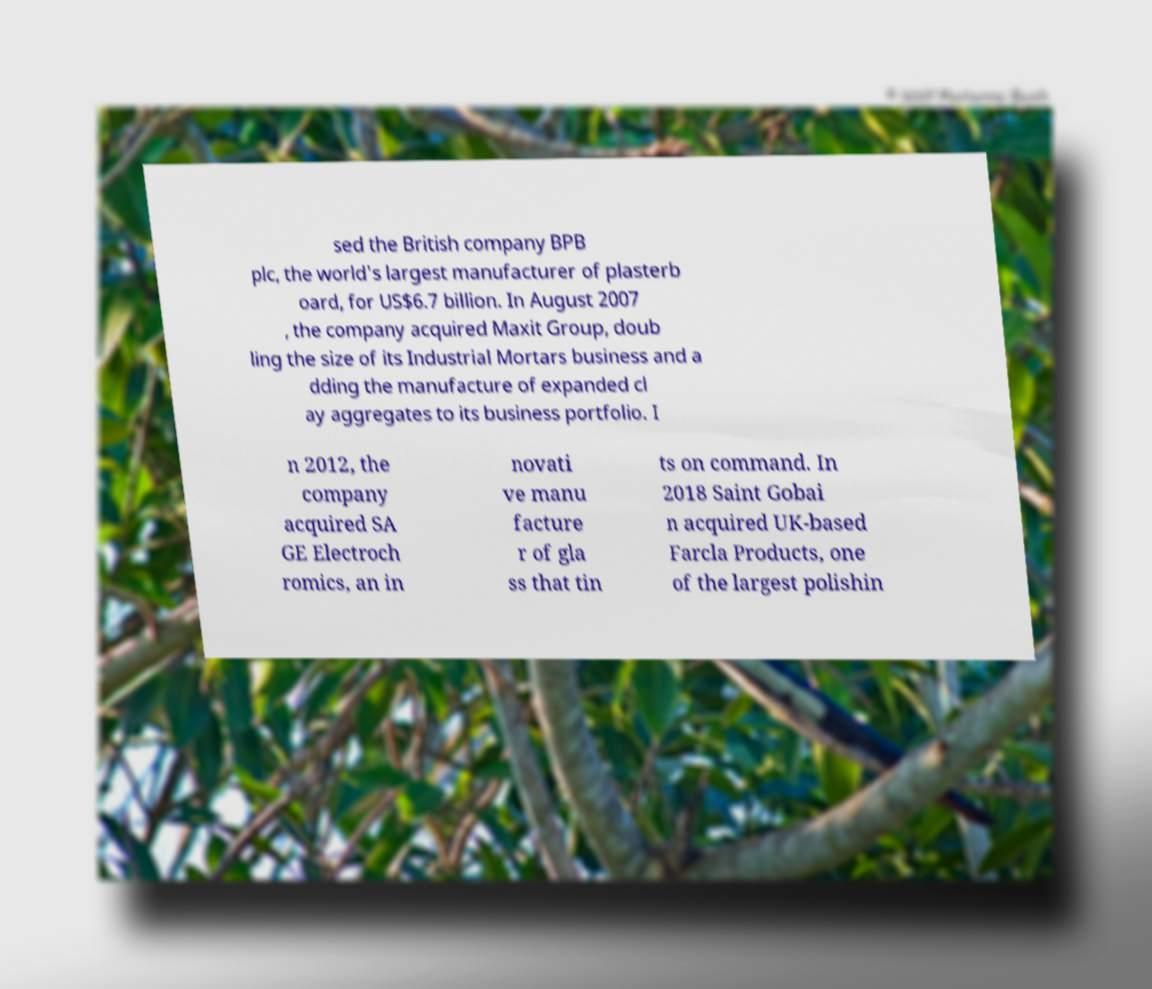I need the written content from this picture converted into text. Can you do that? sed the British company BPB plc, the world's largest manufacturer of plasterb oard, for US$6.7 billion. In August 2007 , the company acquired Maxit Group, doub ling the size of its Industrial Mortars business and a dding the manufacture of expanded cl ay aggregates to its business portfolio. I n 2012, the company acquired SA GE Electroch romics, an in novati ve manu facture r of gla ss that tin ts on command. In 2018 Saint Gobai n acquired UK-based Farcla Products, one of the largest polishin 